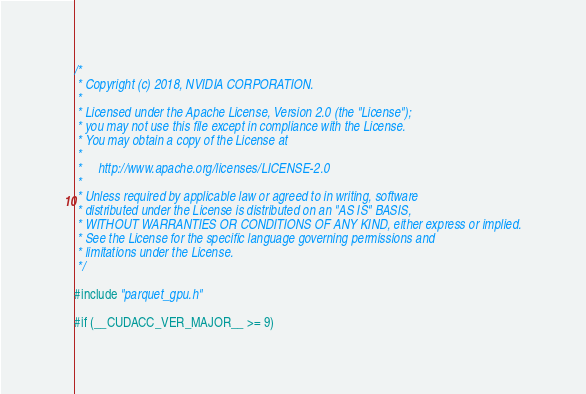<code> <loc_0><loc_0><loc_500><loc_500><_Cuda_>/*
 * Copyright (c) 2018, NVIDIA CORPORATION.
 *
 * Licensed under the Apache License, Version 2.0 (the "License");
 * you may not use this file except in compliance with the License.
 * You may obtain a copy of the License at
 *
 *     http://www.apache.org/licenses/LICENSE-2.0
 *
 * Unless required by applicable law or agreed to in writing, software
 * distributed under the License is distributed on an "AS IS" BASIS,
 * WITHOUT WARRANTIES OR CONDITIONS OF ANY KIND, either express or implied.
 * See the License for the specific language governing permissions and
 * limitations under the License.
 */

#include "parquet_gpu.h"

#if (__CUDACC_VER_MAJOR__ >= 9)</code> 